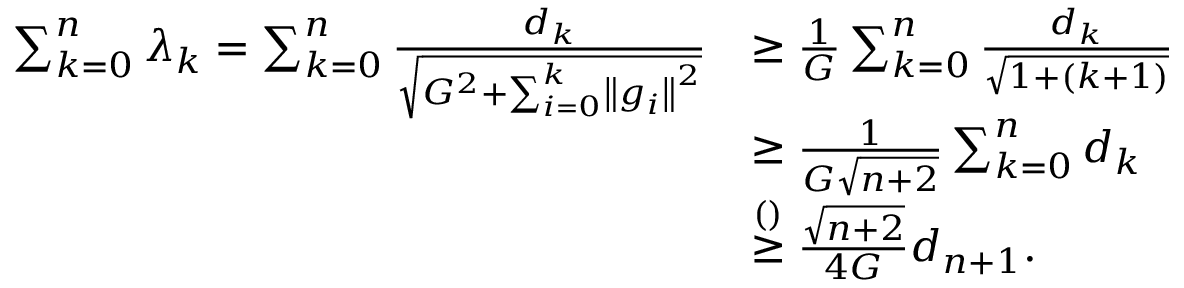Convert formula to latex. <formula><loc_0><loc_0><loc_500><loc_500>\begin{array} { r l } { \sum _ { k = 0 } ^ { n } \lambda _ { k } = \sum _ { k = 0 } ^ { n } \frac { d _ { k } } { \sqrt { G ^ { 2 } + \sum _ { i = 0 } ^ { k } \left \| g _ { i } \right \| ^ { 2 } } } } & { \geq \frac { 1 } { G } \sum _ { k = 0 } ^ { n } \frac { d _ { k } } { \sqrt { 1 + ( k + 1 ) } } } \\ & { \geq \frac { 1 } { G \sqrt { n + 2 } } \sum _ { k = 0 } ^ { n } d _ { k } } \\ & { \stackrel { ( ) } { \geq } \frac { \sqrt { n + 2 } } { 4 G } d _ { n + 1 } . } \end{array}</formula> 